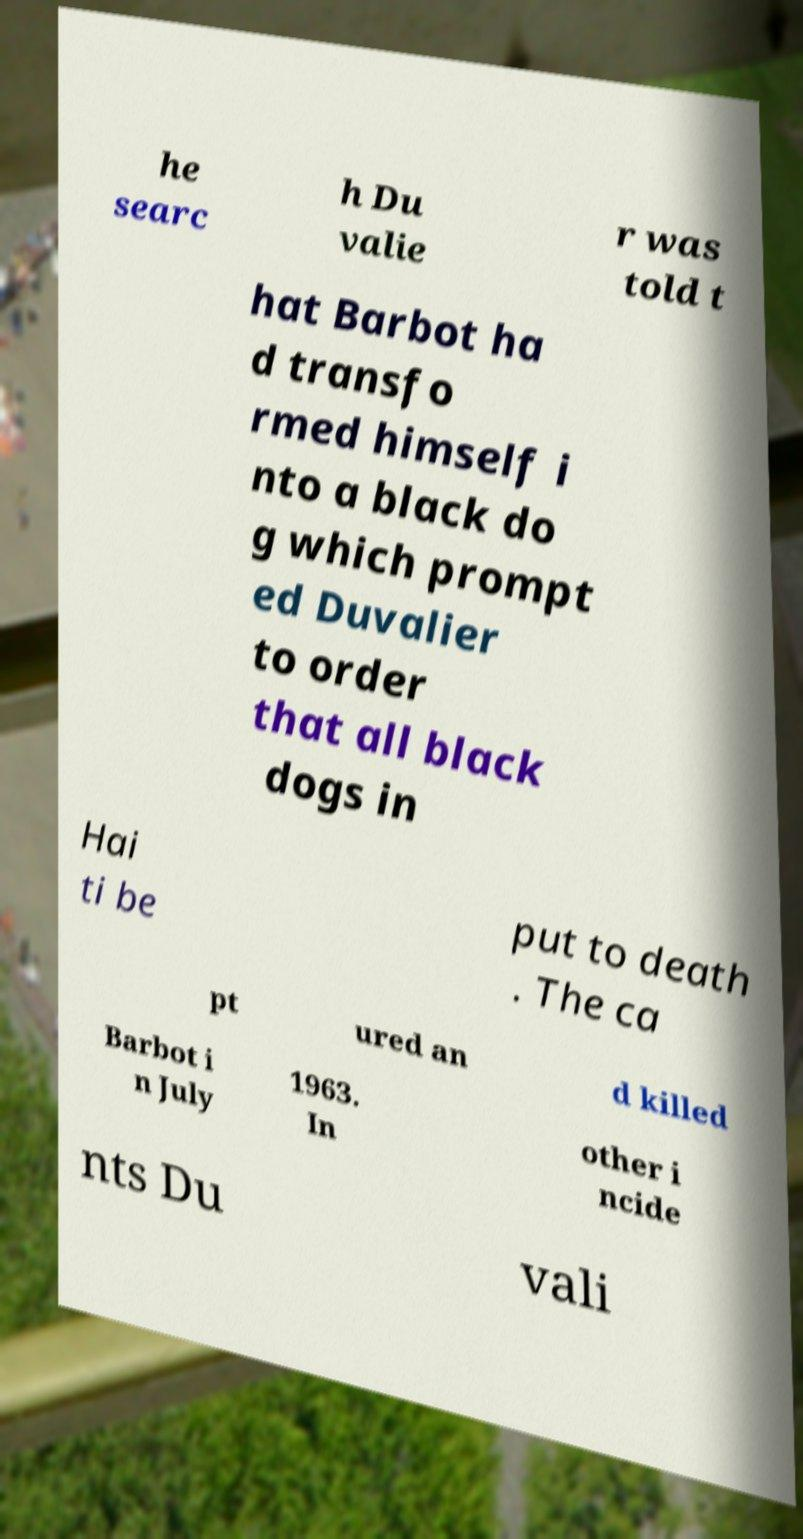Can you read and provide the text displayed in the image?This photo seems to have some interesting text. Can you extract and type it out for me? he searc h Du valie r was told t hat Barbot ha d transfo rmed himself i nto a black do g which prompt ed Duvalier to order that all black dogs in Hai ti be put to death . The ca pt ured an d killed Barbot i n July 1963. In other i ncide nts Du vali 